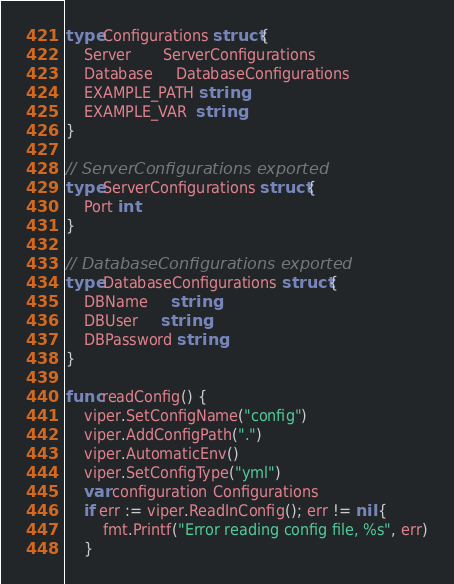<code> <loc_0><loc_0><loc_500><loc_500><_Go_>type Configurations struct {
	Server       ServerConfigurations
	Database     DatabaseConfigurations
	EXAMPLE_PATH string
	EXAMPLE_VAR  string
}

// ServerConfigurations exported
type ServerConfigurations struct {
	Port int
}

// DatabaseConfigurations exported
type DatabaseConfigurations struct {
	DBName     string
	DBUser     string
	DBPassword string
}

func readConfig() {
	viper.SetConfigName("config")
	viper.AddConfigPath(".")
	viper.AutomaticEnv()
	viper.SetConfigType("yml")
	var configuration Configurations
	if err := viper.ReadInConfig(); err != nil {
		fmt.Printf("Error reading config file, %s", err)
	}</code> 